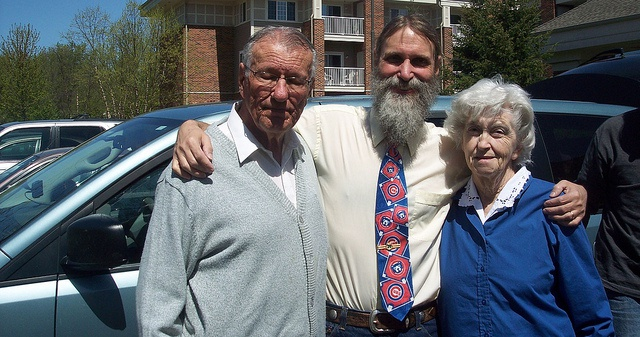Describe the objects in this image and their specific colors. I can see people in gray, darkgray, and lightgray tones, people in gray, lightgray, black, and darkgray tones, car in gray, black, blue, white, and teal tones, people in gray, navy, blue, and black tones, and people in gray, black, and blue tones in this image. 